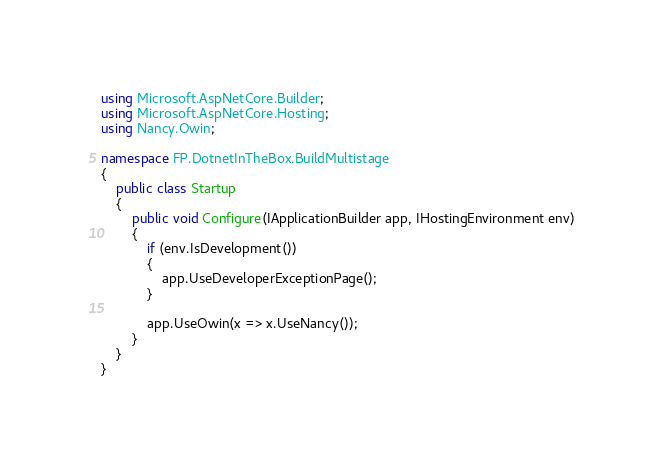Convert code to text. <code><loc_0><loc_0><loc_500><loc_500><_C#_>using Microsoft.AspNetCore.Builder;
using Microsoft.AspNetCore.Hosting;
using Nancy.Owin;

namespace FP.DotnetInTheBox.BuildMultistage
{
    public class Startup
    {
        public void Configure(IApplicationBuilder app, IHostingEnvironment env)
        {
            if (env.IsDevelopment())
            {
                app.UseDeveloperExceptionPage();
            }

            app.UseOwin(x => x.UseNancy());
        }
    }
}</code> 